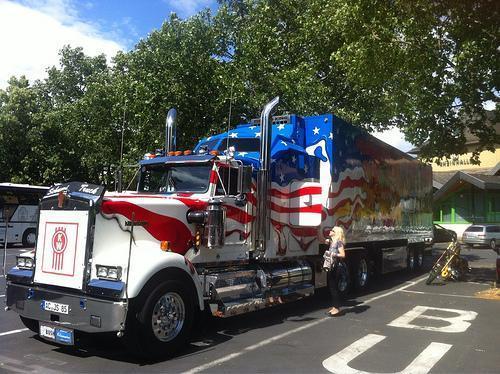How many people are in the picture?
Give a very brief answer. 1. How many large vehicles are pictured?
Give a very brief answer. 2. How many doors on the truck are open?
Give a very brief answer. 1. 